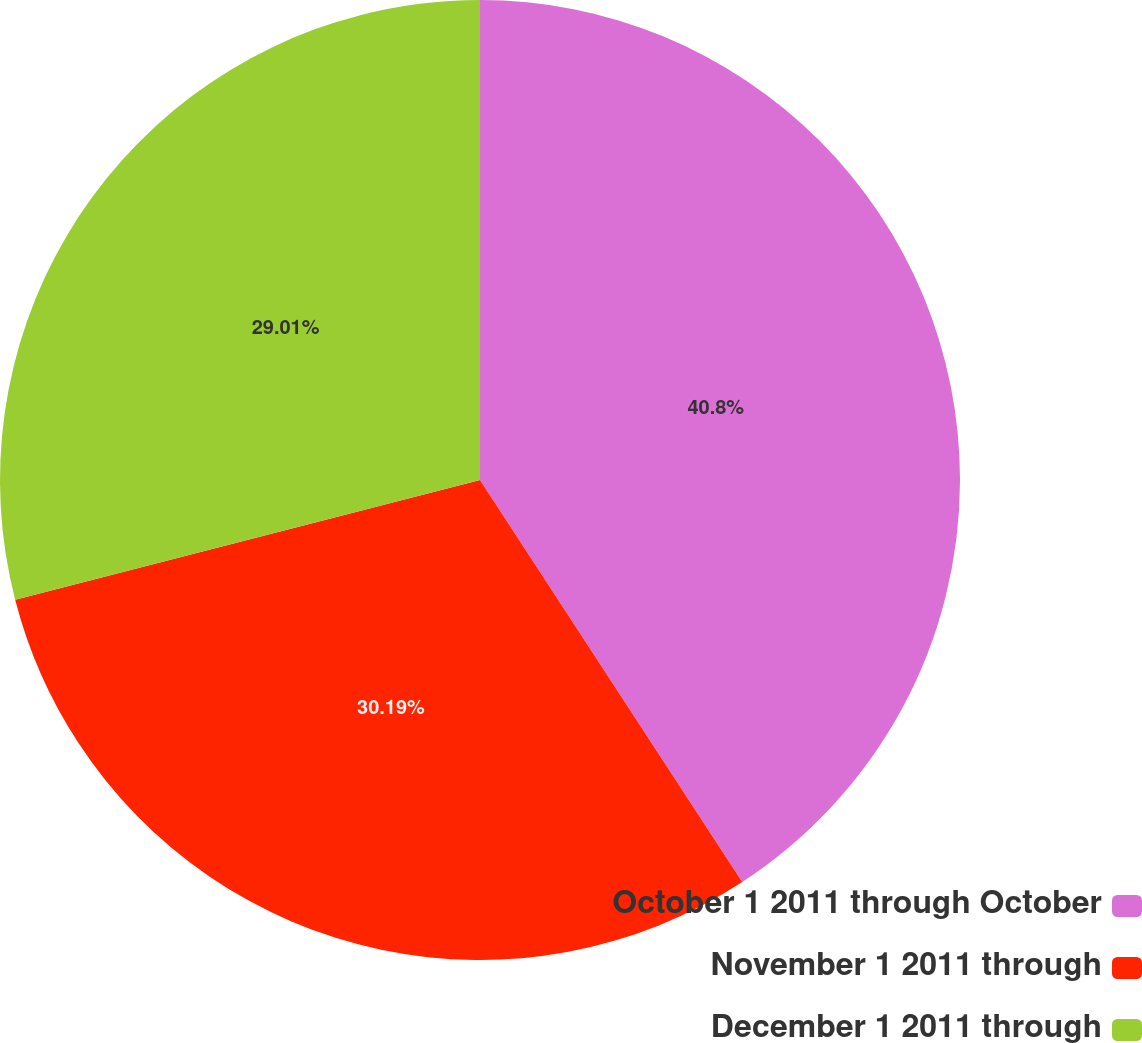Convert chart to OTSL. <chart><loc_0><loc_0><loc_500><loc_500><pie_chart><fcel>October 1 2011 through October<fcel>November 1 2011 through<fcel>December 1 2011 through<nl><fcel>40.8%<fcel>30.19%<fcel>29.01%<nl></chart> 